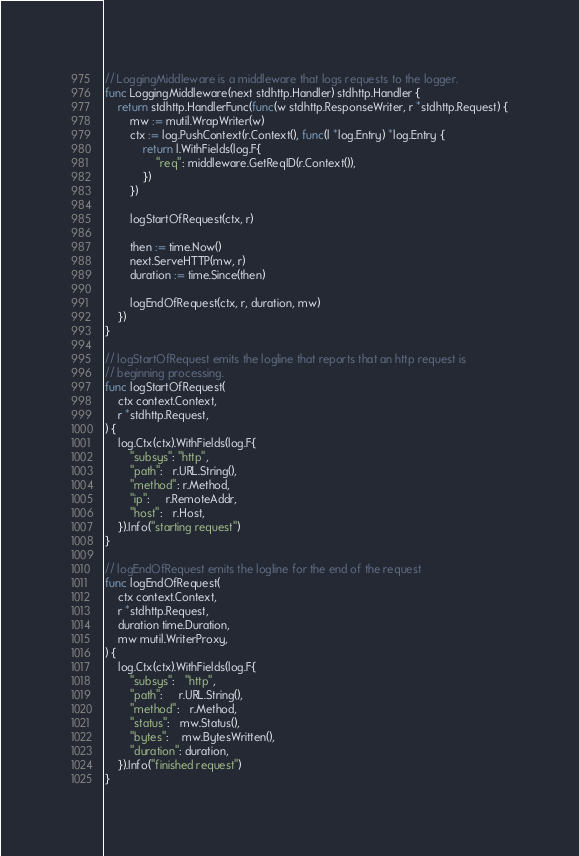<code> <loc_0><loc_0><loc_500><loc_500><_Go_>
// LoggingMiddleware is a middleware that logs requests to the logger.
func LoggingMiddleware(next stdhttp.Handler) stdhttp.Handler {
	return stdhttp.HandlerFunc(func(w stdhttp.ResponseWriter, r *stdhttp.Request) {
		mw := mutil.WrapWriter(w)
		ctx := log.PushContext(r.Context(), func(l *log.Entry) *log.Entry {
			return l.WithFields(log.F{
				"req": middleware.GetReqID(r.Context()),
			})
		})

		logStartOfRequest(ctx, r)

		then := time.Now()
		next.ServeHTTP(mw, r)
		duration := time.Since(then)

		logEndOfRequest(ctx, r, duration, mw)
	})
}

// logStartOfRequest emits the logline that reports that an http request is
// beginning processing.
func logStartOfRequest(
	ctx context.Context,
	r *stdhttp.Request,
) {
	log.Ctx(ctx).WithFields(log.F{
		"subsys": "http",
		"path":   r.URL.String(),
		"method": r.Method,
		"ip":     r.RemoteAddr,
		"host":   r.Host,
	}).Info("starting request")
}

// logEndOfRequest emits the logline for the end of the request
func logEndOfRequest(
	ctx context.Context,
	r *stdhttp.Request,
	duration time.Duration,
	mw mutil.WriterProxy,
) {
	log.Ctx(ctx).WithFields(log.F{
		"subsys":   "http",
		"path":     r.URL.String(),
		"method":   r.Method,
		"status":   mw.Status(),
		"bytes":    mw.BytesWritten(),
		"duration": duration,
	}).Info("finished request")
}
</code> 